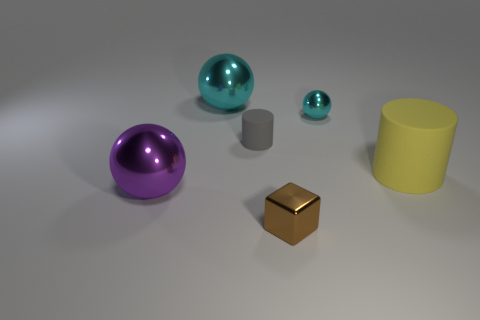Subtract all large balls. How many balls are left? 1 Subtract all purple balls. How many balls are left? 2 Subtract all yellow cylinders. How many cyan balls are left? 2 Subtract 1 balls. How many balls are left? 2 Add 3 big red metallic spheres. How many objects exist? 9 Subtract all red spheres. Subtract all cyan cubes. How many spheres are left? 3 Subtract all blocks. How many objects are left? 5 Subtract 1 cyan spheres. How many objects are left? 5 Subtract all yellow matte blocks. Subtract all large yellow objects. How many objects are left? 5 Add 2 small shiny blocks. How many small shiny blocks are left? 3 